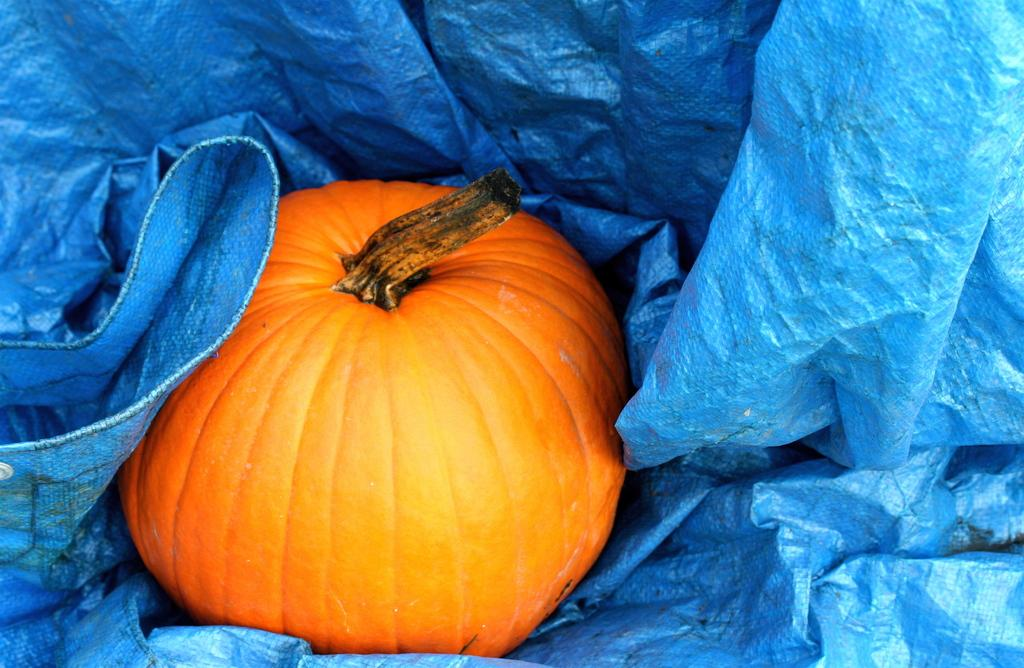What is the main object in the image? There is a pumpkin in the image. What is the pumpkin placed on? The pumpkin is placed on a blue sheet. What type of disgust can be seen on the pumpkin's face in the image? There is no face on the pumpkin, as it is a vegetable, and therefore cannot display any emotions or feelings. 